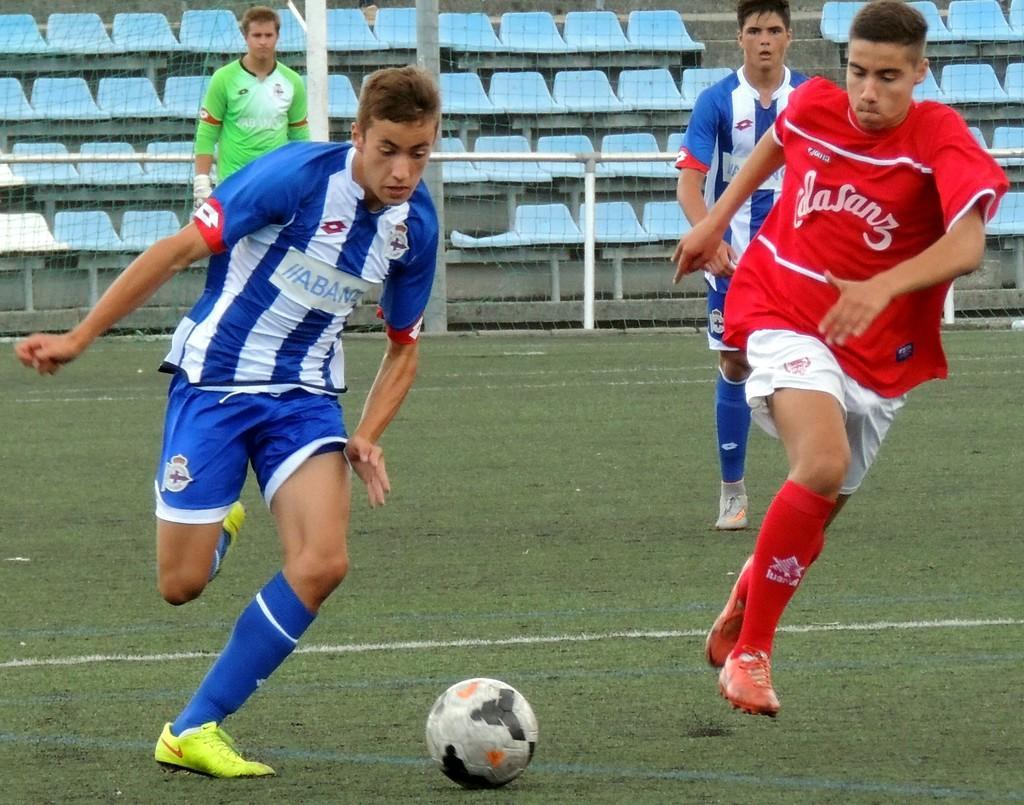Could you give a brief overview of what you see in this image? In the image we can see there are four people playing. This is a ball. 